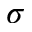Convert formula to latex. <formula><loc_0><loc_0><loc_500><loc_500>\sigma</formula> 